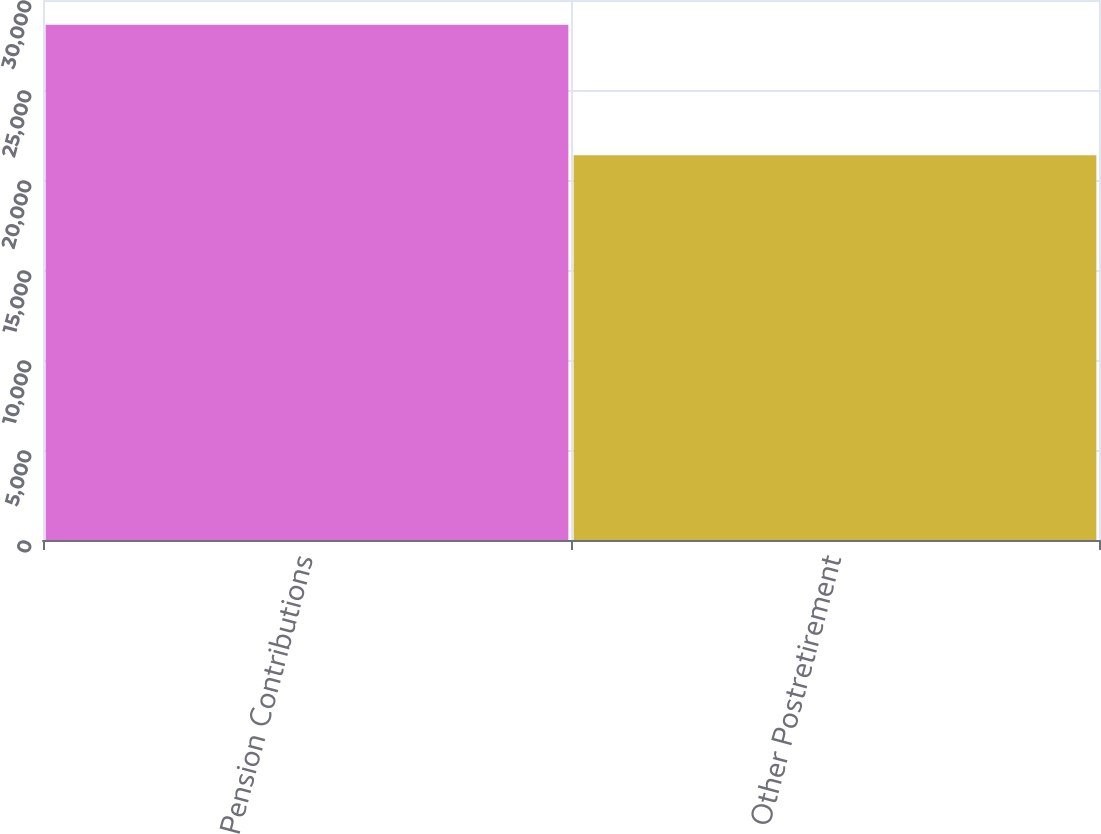Convert chart. <chart><loc_0><loc_0><loc_500><loc_500><bar_chart><fcel>Pension Contributions<fcel>Other Postretirement<nl><fcel>28627<fcel>21377<nl></chart> 